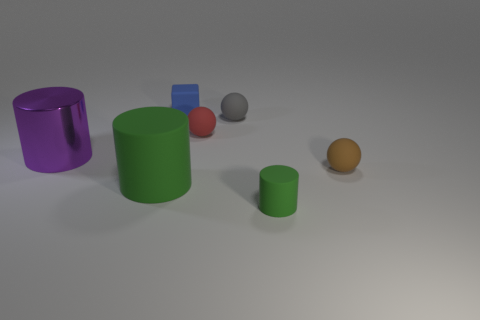Subtract all small matte cylinders. How many cylinders are left? 2 Subtract all cyan balls. How many green cylinders are left? 2 Add 1 tiny rubber cylinders. How many objects exist? 8 Subtract all spheres. How many objects are left? 4 Subtract 0 cyan cubes. How many objects are left? 7 Subtract all blue rubber things. Subtract all matte things. How many objects are left? 0 Add 7 tiny gray balls. How many tiny gray balls are left? 8 Add 1 small red shiny spheres. How many small red shiny spheres exist? 1 